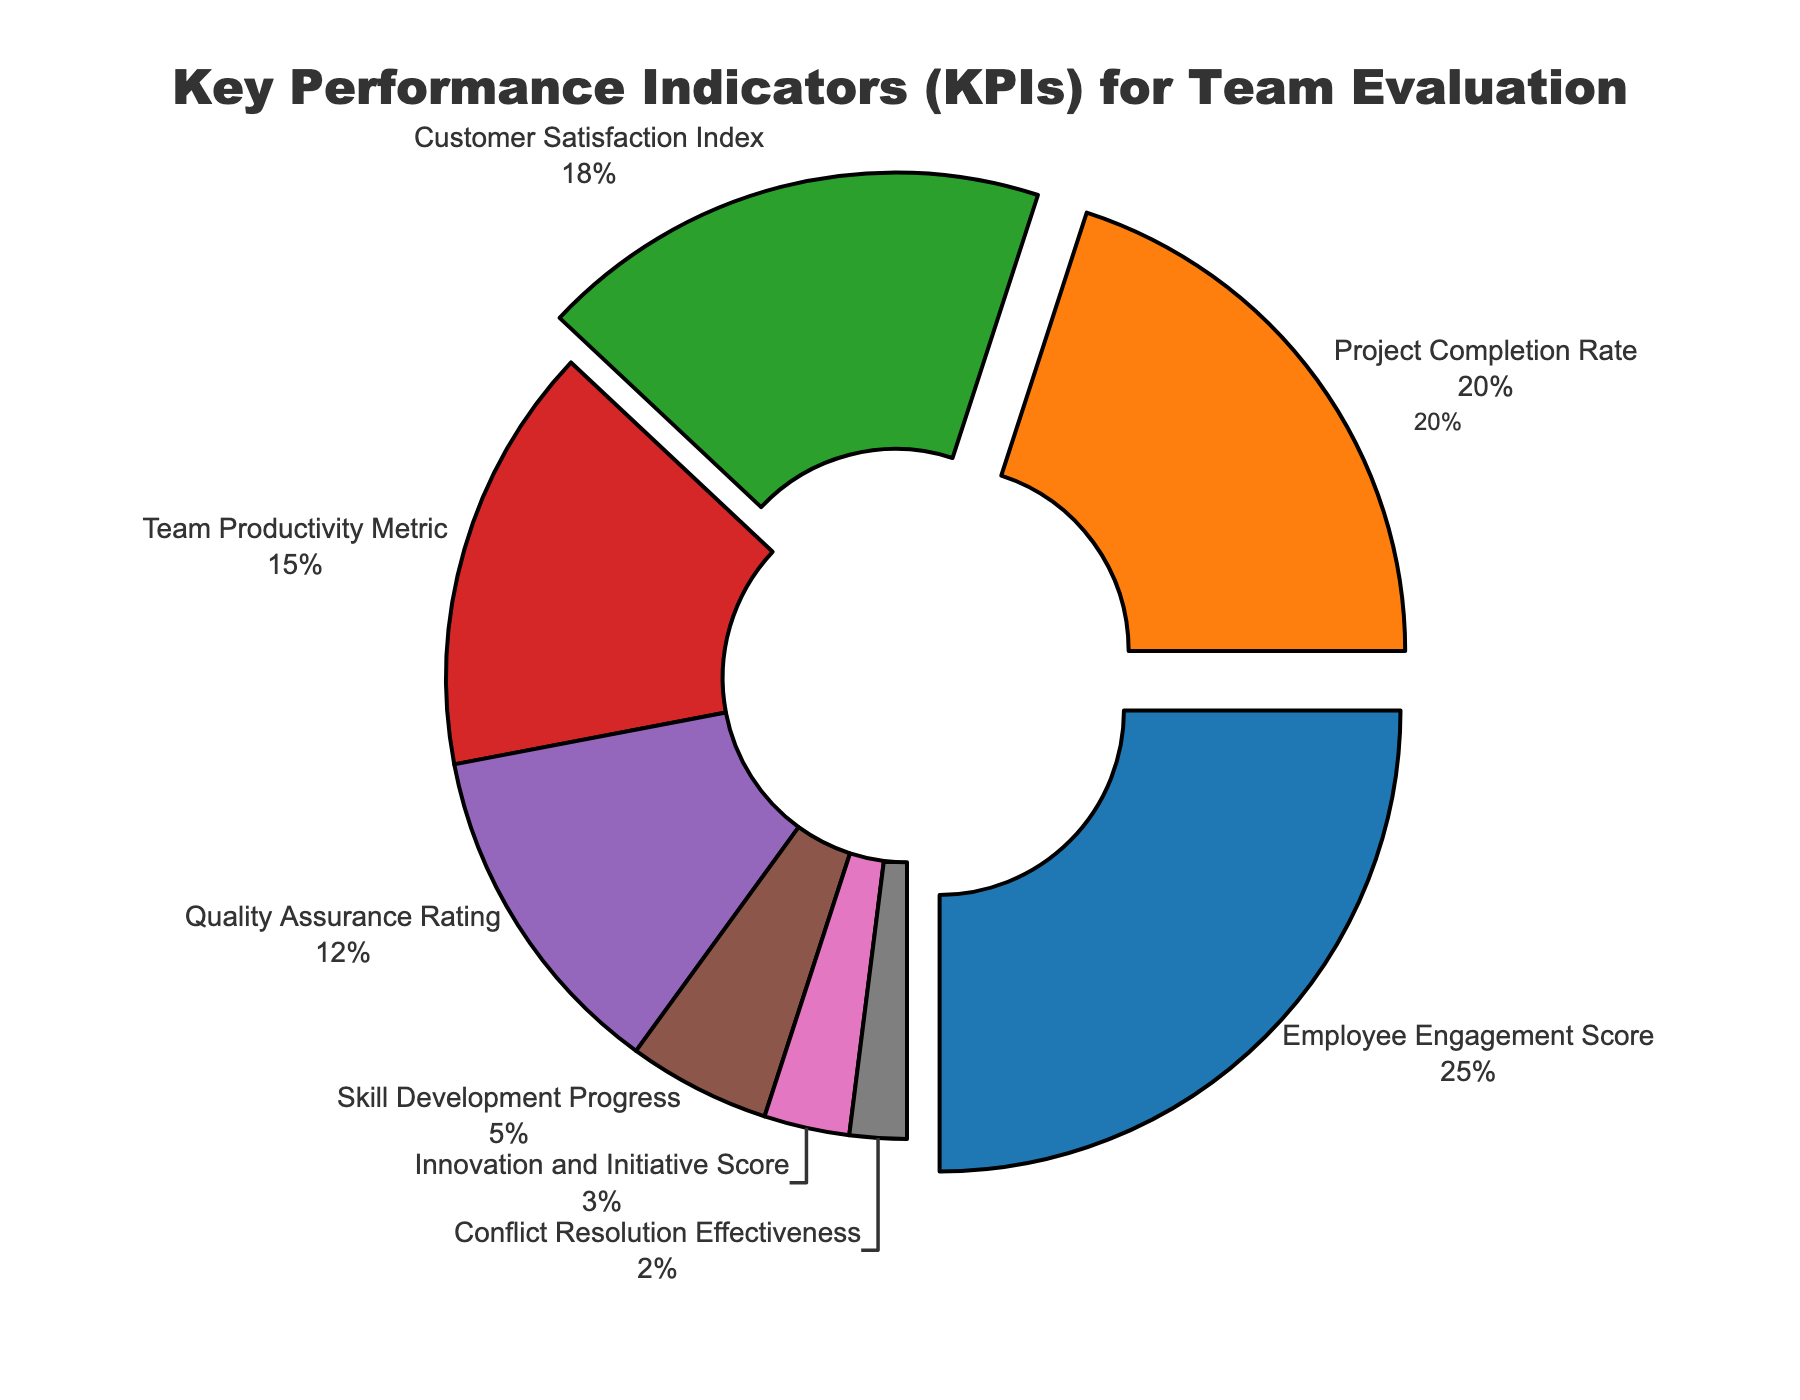what are the three largest KPIs by percentage? The top three KPIs by percentage can be identified as those with the highest values in the pie chart. They are Employee Engagement Score, Project Completion Rate, and Customer Satisfaction Index, as they pull away from the pie chart significantly. The specific figures are 25%, 20%, and 18% respectively.
Answer: Employee Engagement Score, Project Completion Rate, Customer Satisfaction Index what percentage does Team Productivity Metric account for? Observing the pie chart, the 'Team Productivity Metric' slice is highlighted by its label and percentage. It stands at 15%.
Answer: 15% which KPI has the smallest contribution? The smallest segment in the pie chart represents the KPI with the lowest percentage. 'Conflict Resolution Effectiveness' occupies the smallest area and is marked by 2%.
Answer: Conflict Resolution Effectiveness how much more is the Employee Engagement Score compared to Skill Development Progress? Subtract the percentage of Skill Development Progress (5%) from that of Employee Engagement Score (25%) to find the difference (25% - 5%).
Answer: 20% What percentage is accounted for by the combination of Quality Assurance Rating and Skill Development Progress? Add the individual percentages for Quality Assurance Rating (12%) and Skill Development Progress (5%) (12% + 5%).
Answer: 17% How does the percentage of Customer Satisfaction Index compare to the Quality Assurance Rating? Subtract the percentage of Quality Assurance Rating (12%) from Customer Satisfaction Index (18%) to find the difference (18% - 12%).
Answer: 6% Which KPI segments are pulled away from the center, and why? KPIs pulled away from the center are those that have a percentage above 15%. These include Employee Engagement Score, Project Completion Rate, and Customer Satisfaction Index, which have percentages of 25%, 20%, and 18% respectively. These are visually distinguished to indicate their relative significance.
Answer: Employee Engagement Score, Project Completion Rate, Customer Satisfaction Index What is the aggregate percentage of the lowest three KPIs? Combine the percentages of Innovation and Initiative Score (3%), Conflict Resolution Effectiveness (2%), and Skill Development Progress (5%). The sum is 3% + 2% + 5%.
Answer: 10% What is the difference between the sum of the top two KPIs and the bottom two KPIs? First, sum the top two KPIs: Employee Engagement Score (25%) and Project Completion Rate (20%), 25% + 20% = 45%. Next, sum the bottom two KPIs: Conflict Resolution Effectiveness (2%) and Innovation and Initiative Score (3%), 2% + 3% = 5%. Subtract the bottom two sum from the top two sum, 45% - 5%.
Answer: 40% What colors are used to represent Employee Engagement Score and Customer Satisfaction Index? The Employee Engagement Score segment is colored blue, and the Customer Satisfaction Index segment is colored green. These color choices help visually distinguish different KPIs in the pie chart.
Answer: Blue, Green 